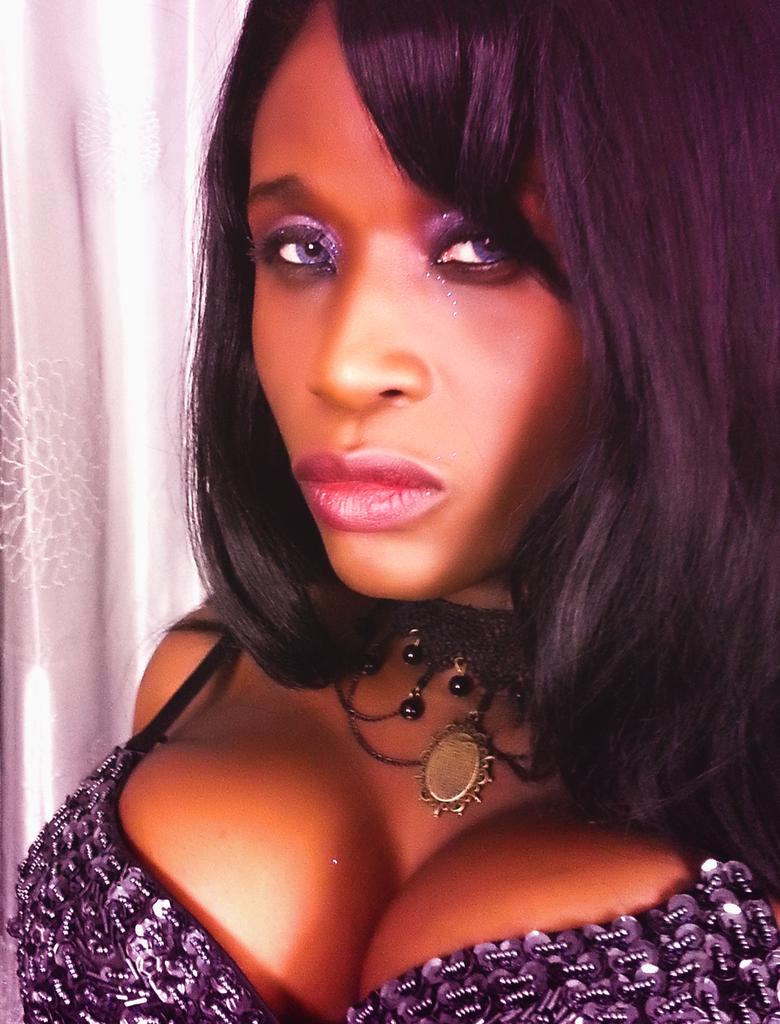What is the main subject of the image? There is a woman in the image. Can you describe the background of the image? There is a white curtain behind the woman in the image. What type of hat is the zebra wearing in the image? There is no zebra or hat present in the image. 